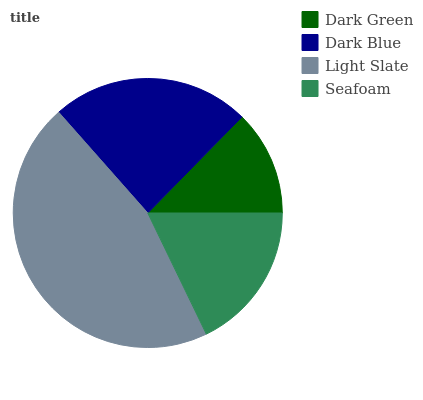Is Dark Green the minimum?
Answer yes or no. Yes. Is Light Slate the maximum?
Answer yes or no. Yes. Is Dark Blue the minimum?
Answer yes or no. No. Is Dark Blue the maximum?
Answer yes or no. No. Is Dark Blue greater than Dark Green?
Answer yes or no. Yes. Is Dark Green less than Dark Blue?
Answer yes or no. Yes. Is Dark Green greater than Dark Blue?
Answer yes or no. No. Is Dark Blue less than Dark Green?
Answer yes or no. No. Is Dark Blue the high median?
Answer yes or no. Yes. Is Seafoam the low median?
Answer yes or no. Yes. Is Light Slate the high median?
Answer yes or no. No. Is Dark Blue the low median?
Answer yes or no. No. 